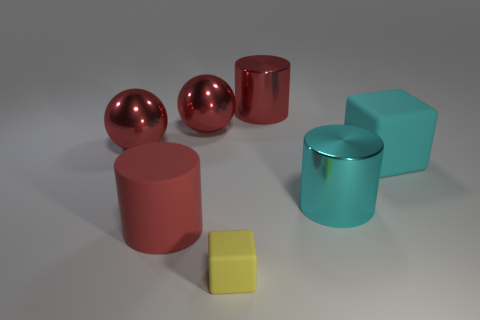Subtract all large cyan cylinders. How many cylinders are left? 2 Subtract all red cylinders. How many cylinders are left? 1 Add 6 metallic balls. How many metallic balls are left? 8 Add 3 yellow matte blocks. How many yellow matte blocks exist? 4 Add 3 large yellow cubes. How many objects exist? 10 Subtract 0 green cylinders. How many objects are left? 7 Subtract all balls. How many objects are left? 5 Subtract 2 cubes. How many cubes are left? 0 Subtract all brown spheres. Subtract all cyan cylinders. How many spheres are left? 2 Subtract all cyan spheres. How many yellow cubes are left? 1 